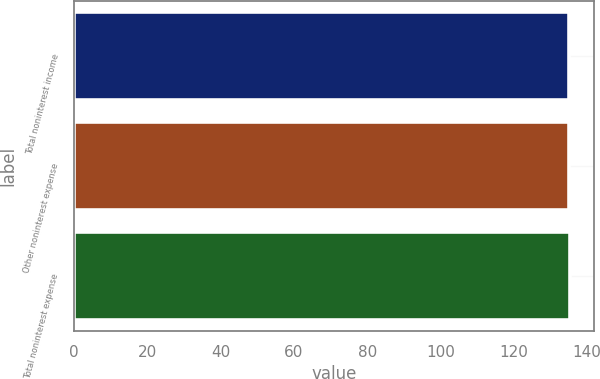Convert chart to OTSL. <chart><loc_0><loc_0><loc_500><loc_500><bar_chart><fcel>Total noninterest income<fcel>Other noninterest expense<fcel>Total noninterest expense<nl><fcel>135<fcel>135.1<fcel>135.2<nl></chart> 